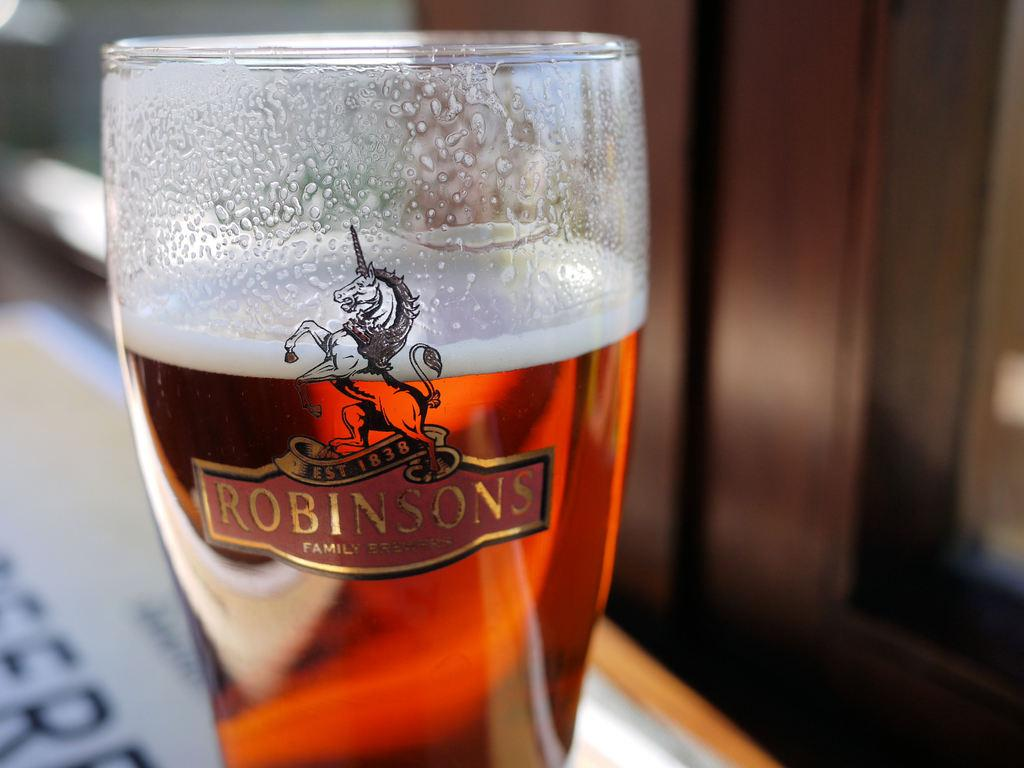<image>
Summarize the visual content of the image. The pint shown in in a Robinsons glass with the picture of a unicorn on it. 